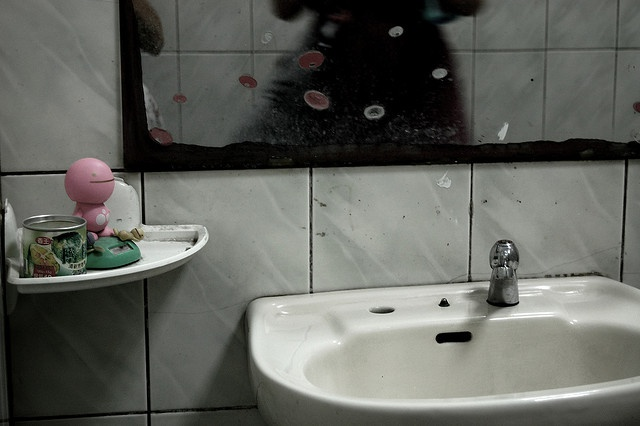Describe the objects in this image and their specific colors. I can see a sink in gray, darkgray, and lightgray tones in this image. 